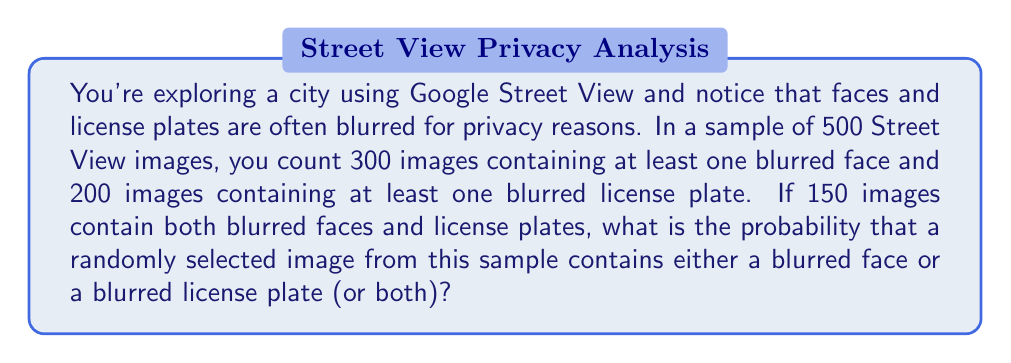Give your solution to this math problem. Let's approach this step-by-step using set theory and probability:

1) Define events:
   A: Image contains at least one blurred face
   B: Image contains at least one blurred license plate

2) Given information:
   Total images: n = 500
   P(A) = 300/500 = 3/5
   P(B) = 200/500 = 2/5
   P(A ∩ B) = 150/500 = 3/10

3) We need to find P(A ∪ B), which is the probability of an image containing either a blurred face or a blurred license plate (or both).

4) Use the addition rule of probability:
   P(A ∪ B) = P(A) + P(B) - P(A ∩ B)

5) Substitute the values:
   P(A ∪ B) = 3/5 + 2/5 - 3/10

6) Simplify:
   P(A ∪ B) = 6/10 + 4/10 - 3/10
             = (6 + 4 - 3)/10
             = 7/10

7) Convert to a percentage:
   7/10 * 100% = 70%

Therefore, the probability of a randomly selected image containing either a blurred face or a blurred license plate (or both) is 7/10 or 70%.
Answer: $$\frac{7}{10}$$ or 70% 